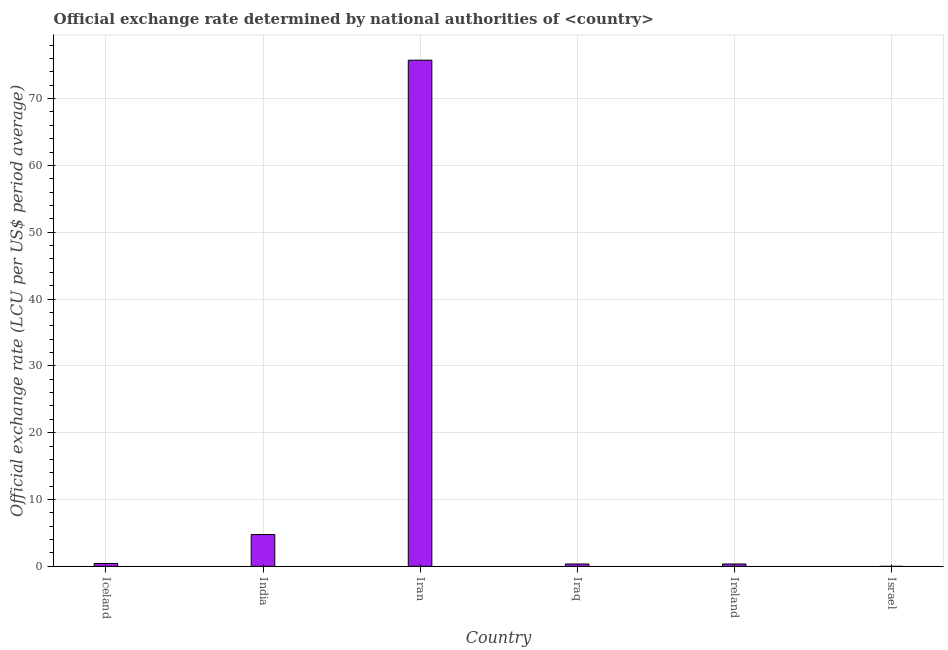Does the graph contain grids?
Make the answer very short. Yes. What is the title of the graph?
Give a very brief answer. Official exchange rate determined by national authorities of <country>. What is the label or title of the X-axis?
Make the answer very short. Country. What is the label or title of the Y-axis?
Make the answer very short. Official exchange rate (LCU per US$ period average). What is the official exchange rate in Iraq?
Your answer should be very brief. 0.36. Across all countries, what is the maximum official exchange rate?
Your answer should be very brief. 75.75. Across all countries, what is the minimum official exchange rate?
Offer a very short reply. 0. In which country was the official exchange rate maximum?
Your response must be concise. Iran. In which country was the official exchange rate minimum?
Ensure brevity in your answer.  Israel. What is the sum of the official exchange rate?
Your answer should be compact. 81.66. What is the difference between the official exchange rate in Iran and Israel?
Your answer should be compact. 75.75. What is the average official exchange rate per country?
Provide a succinct answer. 13.61. What is the median official exchange rate?
Your response must be concise. 0.39. In how many countries, is the official exchange rate greater than 62 ?
Give a very brief answer. 1. What is the ratio of the official exchange rate in India to that in Iraq?
Provide a short and direct response. 13.33. Is the official exchange rate in Iceland less than that in India?
Your answer should be very brief. Yes. Is the difference between the official exchange rate in Iran and Israel greater than the difference between any two countries?
Provide a short and direct response. Yes. What is the difference between the highest and the second highest official exchange rate?
Offer a very short reply. 70.99. What is the difference between the highest and the lowest official exchange rate?
Make the answer very short. 75.75. In how many countries, is the official exchange rate greater than the average official exchange rate taken over all countries?
Your answer should be very brief. 1. How many bars are there?
Provide a short and direct response. 6. Are all the bars in the graph horizontal?
Offer a terse response. No. How many countries are there in the graph?
Provide a succinct answer. 6. What is the difference between two consecutive major ticks on the Y-axis?
Your answer should be compact. 10. Are the values on the major ticks of Y-axis written in scientific E-notation?
Make the answer very short. No. What is the Official exchange rate (LCU per US$ period average) in Iceland?
Your answer should be very brief. 0.43. What is the Official exchange rate (LCU per US$ period average) in India?
Your response must be concise. 4.76. What is the Official exchange rate (LCU per US$ period average) in Iran?
Provide a short and direct response. 75.75. What is the Official exchange rate (LCU per US$ period average) in Iraq?
Provide a short and direct response. 0.36. What is the Official exchange rate (LCU per US$ period average) of Ireland?
Ensure brevity in your answer.  0.36. What is the Official exchange rate (LCU per US$ period average) in Israel?
Your answer should be very brief. 0. What is the difference between the Official exchange rate (LCU per US$ period average) in Iceland and India?
Provide a succinct answer. -4.33. What is the difference between the Official exchange rate (LCU per US$ period average) in Iceland and Iran?
Your response must be concise. -75.32. What is the difference between the Official exchange rate (LCU per US$ period average) in Iceland and Iraq?
Your answer should be very brief. 0.07. What is the difference between the Official exchange rate (LCU per US$ period average) in Iceland and Ireland?
Offer a very short reply. 0.07. What is the difference between the Official exchange rate (LCU per US$ period average) in Iceland and Israel?
Offer a very short reply. 0.43. What is the difference between the Official exchange rate (LCU per US$ period average) in India and Iran?
Your response must be concise. -70.99. What is the difference between the Official exchange rate (LCU per US$ period average) in India and Iraq?
Make the answer very short. 4.4. What is the difference between the Official exchange rate (LCU per US$ period average) in India and Ireland?
Provide a short and direct response. 4.4. What is the difference between the Official exchange rate (LCU per US$ period average) in India and Israel?
Make the answer very short. 4.76. What is the difference between the Official exchange rate (LCU per US$ period average) in Iran and Iraq?
Your answer should be very brief. 75.39. What is the difference between the Official exchange rate (LCU per US$ period average) in Iran and Ireland?
Make the answer very short. 75.39. What is the difference between the Official exchange rate (LCU per US$ period average) in Iran and Israel?
Provide a succinct answer. 75.75. What is the difference between the Official exchange rate (LCU per US$ period average) in Iraq and Ireland?
Keep it short and to the point. 0. What is the difference between the Official exchange rate (LCU per US$ period average) in Iraq and Israel?
Ensure brevity in your answer.  0.36. What is the difference between the Official exchange rate (LCU per US$ period average) in Ireland and Israel?
Keep it short and to the point. 0.36. What is the ratio of the Official exchange rate (LCU per US$ period average) in Iceland to that in India?
Your answer should be compact. 0.09. What is the ratio of the Official exchange rate (LCU per US$ period average) in Iceland to that in Iran?
Provide a succinct answer. 0.01. What is the ratio of the Official exchange rate (LCU per US$ period average) in Iceland to that in Iraq?
Ensure brevity in your answer.  1.2. What is the ratio of the Official exchange rate (LCU per US$ period average) in Iceland to that in Ireland?
Offer a terse response. 1.2. What is the ratio of the Official exchange rate (LCU per US$ period average) in Iceland to that in Israel?
Your answer should be very brief. 1482.76. What is the ratio of the Official exchange rate (LCU per US$ period average) in India to that in Iran?
Offer a very short reply. 0.06. What is the ratio of the Official exchange rate (LCU per US$ period average) in India to that in Iraq?
Offer a terse response. 13.33. What is the ratio of the Official exchange rate (LCU per US$ period average) in India to that in Ireland?
Your answer should be very brief. 13.33. What is the ratio of the Official exchange rate (LCU per US$ period average) in India to that in Israel?
Offer a very short reply. 1.64e+04. What is the ratio of the Official exchange rate (LCU per US$ period average) in Iran to that in Iraq?
Your answer should be compact. 212.1. What is the ratio of the Official exchange rate (LCU per US$ period average) in Iran to that in Ireland?
Ensure brevity in your answer.  212.1. What is the ratio of the Official exchange rate (LCU per US$ period average) in Iran to that in Israel?
Ensure brevity in your answer.  2.61e+05. What is the ratio of the Official exchange rate (LCU per US$ period average) in Iraq to that in Israel?
Provide a short and direct response. 1231.53. What is the ratio of the Official exchange rate (LCU per US$ period average) in Ireland to that in Israel?
Ensure brevity in your answer.  1231.53. 